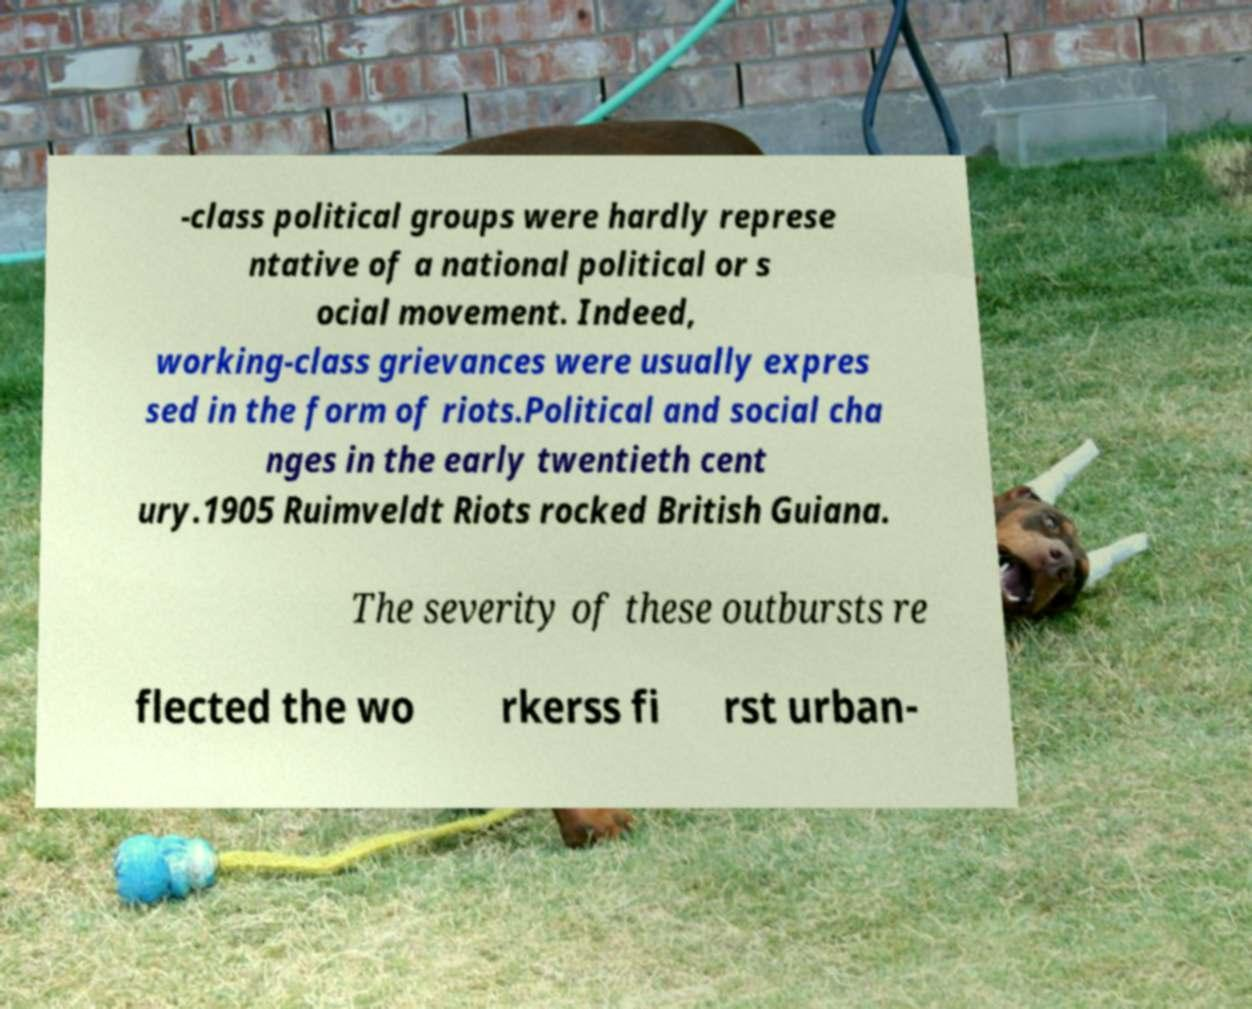What messages or text are displayed in this image? I need them in a readable, typed format. -class political groups were hardly represe ntative of a national political or s ocial movement. Indeed, working-class grievances were usually expres sed in the form of riots.Political and social cha nges in the early twentieth cent ury.1905 Ruimveldt Riots rocked British Guiana. The severity of these outbursts re flected the wo rkerss fi rst urban- 